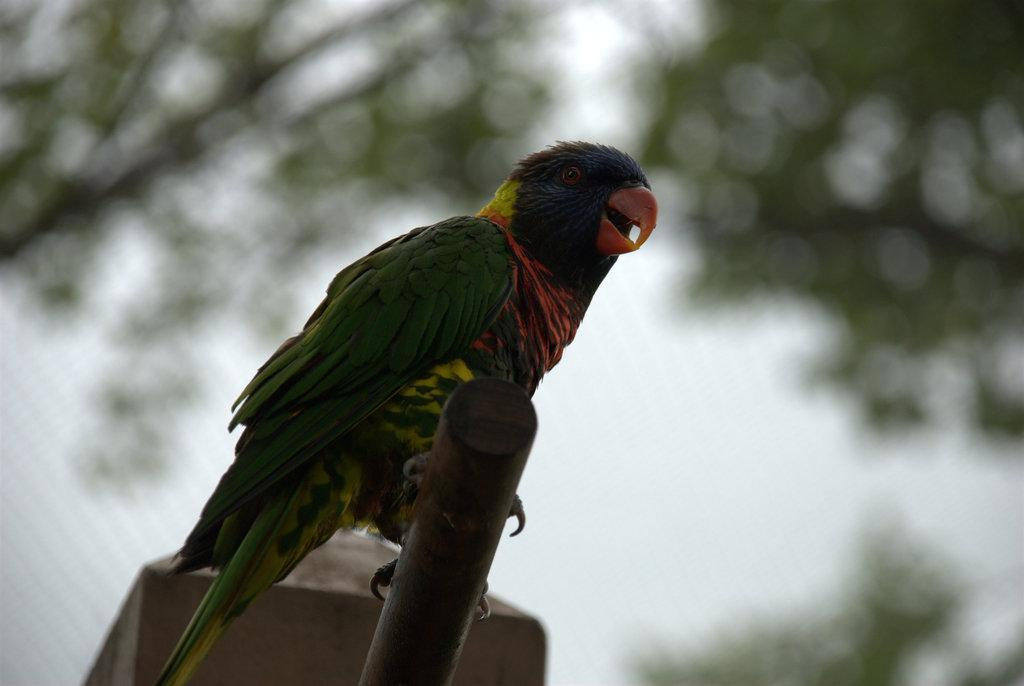What type of animal is present in the image? There is a bird in the image. Where is the bird located? The bird is on a rod. Can you describe the background of the image? The background of the image is not clear. What type of knot is the bird using to secure itself to the rod? There is no knot present in the image, as the bird is not tied to the rod. What type of print can be seen on the bird's feathers? There is no print visible on the bird's feathers in the image. 